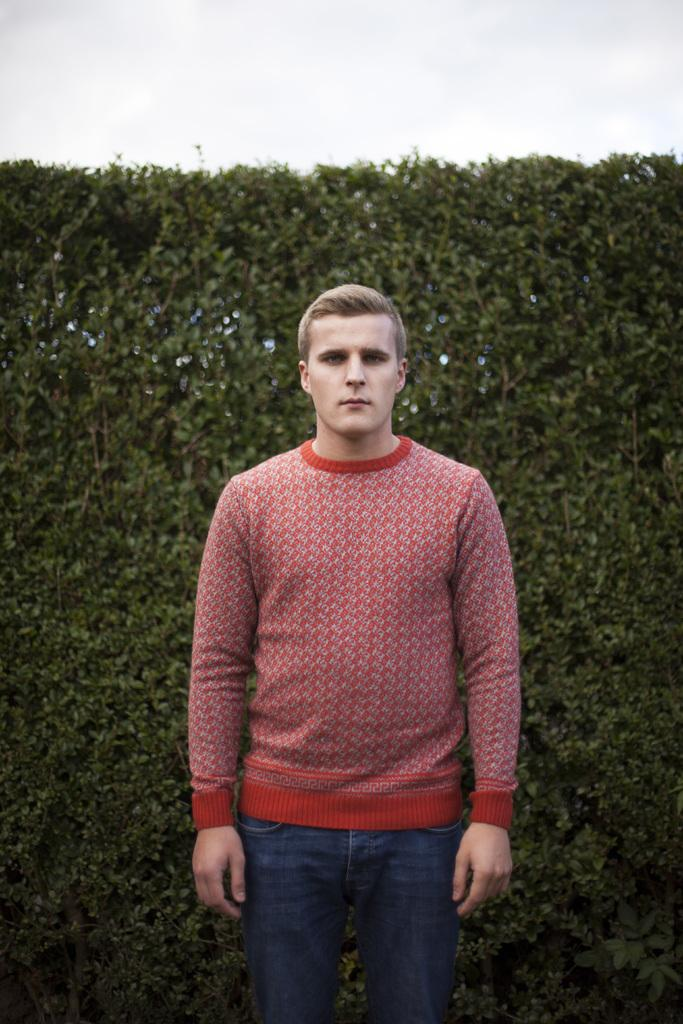What is the main subject of the image? There is a man standing in the image. Can you describe the man's clothing? The man is wearing a red T-shirt with designs. What can be seen in the background of the image? There is a plants wall and the sky visible in the background of the image. How many ducks are visible in the image? There are no ducks present in the image. Is the man in the image jumping or performing any physical activity? The image does not show the man jumping or performing any physical activity; he is simply standing. 